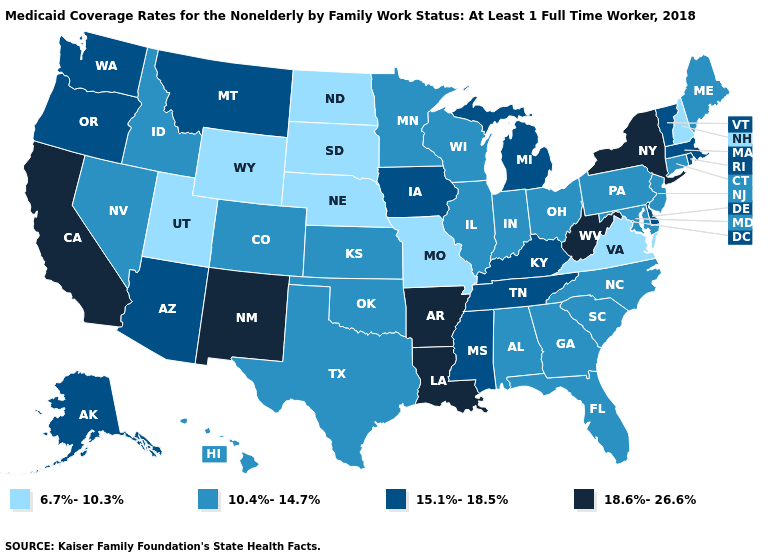Among the states that border South Dakota , does Montana have the lowest value?
Answer briefly. No. What is the highest value in states that border South Carolina?
Quick response, please. 10.4%-14.7%. Among the states that border Arizona , does Nevada have the lowest value?
Keep it brief. No. Among the states that border Pennsylvania , does Ohio have the lowest value?
Short answer required. Yes. What is the value of New York?
Keep it brief. 18.6%-26.6%. Among the states that border Illinois , does Kentucky have the lowest value?
Concise answer only. No. What is the value of California?
Give a very brief answer. 18.6%-26.6%. Does Delaware have the highest value in the USA?
Give a very brief answer. No. Name the states that have a value in the range 15.1%-18.5%?
Quick response, please. Alaska, Arizona, Delaware, Iowa, Kentucky, Massachusetts, Michigan, Mississippi, Montana, Oregon, Rhode Island, Tennessee, Vermont, Washington. Name the states that have a value in the range 10.4%-14.7%?
Answer briefly. Alabama, Colorado, Connecticut, Florida, Georgia, Hawaii, Idaho, Illinois, Indiana, Kansas, Maine, Maryland, Minnesota, Nevada, New Jersey, North Carolina, Ohio, Oklahoma, Pennsylvania, South Carolina, Texas, Wisconsin. Does Utah have a higher value than North Dakota?
Keep it brief. No. Does the first symbol in the legend represent the smallest category?
Write a very short answer. Yes. Does Kentucky have the highest value in the USA?
Be succinct. No. Name the states that have a value in the range 6.7%-10.3%?
Write a very short answer. Missouri, Nebraska, New Hampshire, North Dakota, South Dakota, Utah, Virginia, Wyoming. 